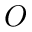Convert formula to latex. <formula><loc_0><loc_0><loc_500><loc_500>O</formula> 